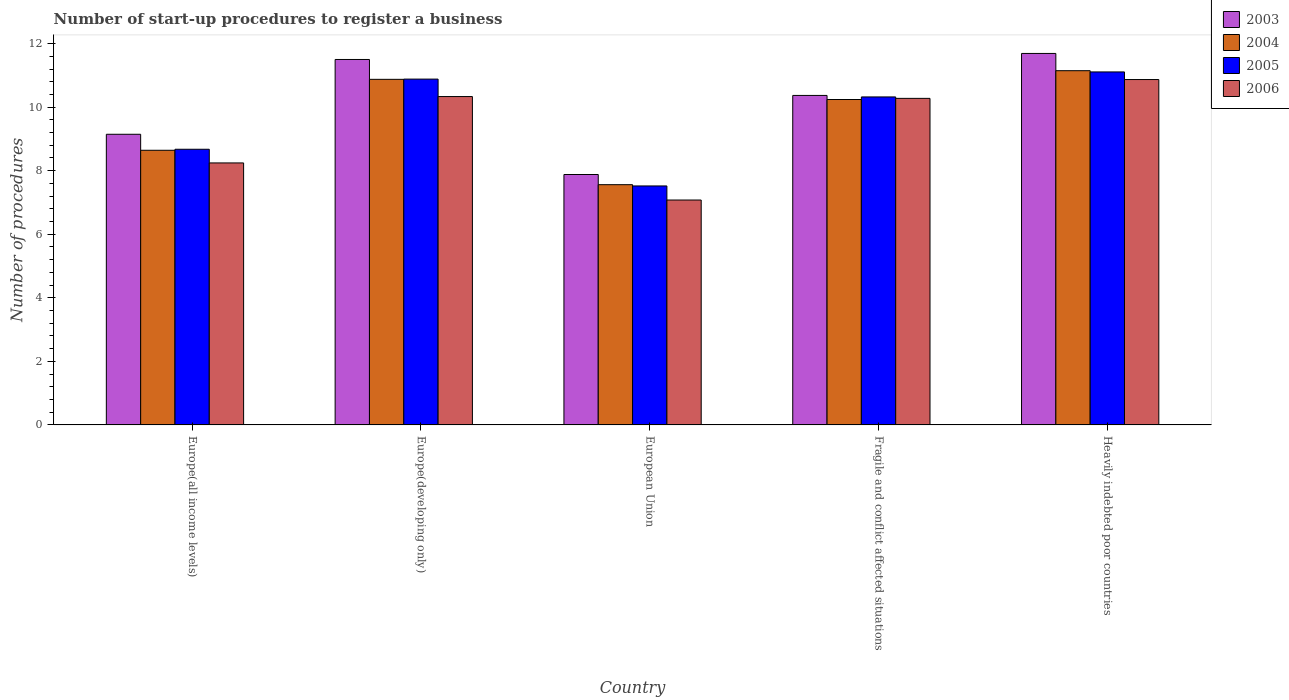How many bars are there on the 3rd tick from the left?
Your answer should be very brief. 4. In how many cases, is the number of bars for a given country not equal to the number of legend labels?
Offer a very short reply. 0. What is the number of procedures required to register a business in 2005 in Heavily indebted poor countries?
Your answer should be compact. 11.11. Across all countries, what is the maximum number of procedures required to register a business in 2003?
Make the answer very short. 11.69. Across all countries, what is the minimum number of procedures required to register a business in 2004?
Your response must be concise. 7.56. In which country was the number of procedures required to register a business in 2004 maximum?
Ensure brevity in your answer.  Heavily indebted poor countries. In which country was the number of procedures required to register a business in 2004 minimum?
Provide a succinct answer. European Union. What is the total number of procedures required to register a business in 2006 in the graph?
Offer a terse response. 46.8. What is the difference between the number of procedures required to register a business in 2005 in European Union and that in Fragile and conflict affected situations?
Ensure brevity in your answer.  -2.8. What is the difference between the number of procedures required to register a business in 2004 in Europe(all income levels) and the number of procedures required to register a business in 2003 in Fragile and conflict affected situations?
Your answer should be very brief. -1.73. What is the average number of procedures required to register a business in 2005 per country?
Your answer should be compact. 9.7. What is the difference between the number of procedures required to register a business of/in 2003 and number of procedures required to register a business of/in 2004 in European Union?
Keep it short and to the point. 0.32. In how many countries, is the number of procedures required to register a business in 2006 greater than 11.6?
Your response must be concise. 0. What is the ratio of the number of procedures required to register a business in 2005 in Europe(all income levels) to that in European Union?
Make the answer very short. 1.15. Is the number of procedures required to register a business in 2004 in Fragile and conflict affected situations less than that in Heavily indebted poor countries?
Offer a terse response. Yes. Is the difference between the number of procedures required to register a business in 2003 in European Union and Heavily indebted poor countries greater than the difference between the number of procedures required to register a business in 2004 in European Union and Heavily indebted poor countries?
Ensure brevity in your answer.  No. What is the difference between the highest and the second highest number of procedures required to register a business in 2003?
Your response must be concise. 1.13. What is the difference between the highest and the lowest number of procedures required to register a business in 2005?
Keep it short and to the point. 3.59. What does the 2nd bar from the right in European Union represents?
Ensure brevity in your answer.  2005. How many legend labels are there?
Provide a short and direct response. 4. What is the title of the graph?
Offer a very short reply. Number of start-up procedures to register a business. What is the label or title of the Y-axis?
Give a very brief answer. Number of procedures. What is the Number of procedures in 2003 in Europe(all income levels)?
Keep it short and to the point. 9.15. What is the Number of procedures of 2004 in Europe(all income levels)?
Ensure brevity in your answer.  8.64. What is the Number of procedures of 2005 in Europe(all income levels)?
Provide a succinct answer. 8.67. What is the Number of procedures in 2006 in Europe(all income levels)?
Keep it short and to the point. 8.24. What is the Number of procedures of 2004 in Europe(developing only)?
Your answer should be compact. 10.88. What is the Number of procedures in 2005 in Europe(developing only)?
Give a very brief answer. 10.88. What is the Number of procedures of 2006 in Europe(developing only)?
Give a very brief answer. 10.33. What is the Number of procedures of 2003 in European Union?
Provide a short and direct response. 7.88. What is the Number of procedures of 2004 in European Union?
Provide a short and direct response. 7.56. What is the Number of procedures in 2005 in European Union?
Your response must be concise. 7.52. What is the Number of procedures of 2006 in European Union?
Provide a succinct answer. 7.08. What is the Number of procedures in 2003 in Fragile and conflict affected situations?
Your answer should be very brief. 10.37. What is the Number of procedures in 2004 in Fragile and conflict affected situations?
Your response must be concise. 10.24. What is the Number of procedures of 2005 in Fragile and conflict affected situations?
Ensure brevity in your answer.  10.32. What is the Number of procedures of 2006 in Fragile and conflict affected situations?
Make the answer very short. 10.28. What is the Number of procedures of 2003 in Heavily indebted poor countries?
Offer a very short reply. 11.69. What is the Number of procedures of 2004 in Heavily indebted poor countries?
Provide a short and direct response. 11.15. What is the Number of procedures in 2005 in Heavily indebted poor countries?
Your answer should be very brief. 11.11. What is the Number of procedures of 2006 in Heavily indebted poor countries?
Provide a succinct answer. 10.87. Across all countries, what is the maximum Number of procedures in 2003?
Your response must be concise. 11.69. Across all countries, what is the maximum Number of procedures in 2004?
Offer a terse response. 11.15. Across all countries, what is the maximum Number of procedures in 2005?
Keep it short and to the point. 11.11. Across all countries, what is the maximum Number of procedures of 2006?
Ensure brevity in your answer.  10.87. Across all countries, what is the minimum Number of procedures in 2003?
Your answer should be very brief. 7.88. Across all countries, what is the minimum Number of procedures of 2004?
Give a very brief answer. 7.56. Across all countries, what is the minimum Number of procedures of 2005?
Your answer should be very brief. 7.52. Across all countries, what is the minimum Number of procedures in 2006?
Provide a short and direct response. 7.08. What is the total Number of procedures in 2003 in the graph?
Give a very brief answer. 50.58. What is the total Number of procedures of 2004 in the graph?
Make the answer very short. 48.46. What is the total Number of procedures of 2005 in the graph?
Your answer should be compact. 48.51. What is the total Number of procedures in 2006 in the graph?
Keep it short and to the point. 46.8. What is the difference between the Number of procedures of 2003 in Europe(all income levels) and that in Europe(developing only)?
Provide a succinct answer. -2.35. What is the difference between the Number of procedures in 2004 in Europe(all income levels) and that in Europe(developing only)?
Ensure brevity in your answer.  -2.23. What is the difference between the Number of procedures in 2005 in Europe(all income levels) and that in Europe(developing only)?
Give a very brief answer. -2.21. What is the difference between the Number of procedures of 2006 in Europe(all income levels) and that in Europe(developing only)?
Offer a terse response. -2.09. What is the difference between the Number of procedures in 2003 in Europe(all income levels) and that in European Union?
Keep it short and to the point. 1.27. What is the difference between the Number of procedures in 2004 in Europe(all income levels) and that in European Union?
Provide a succinct answer. 1.08. What is the difference between the Number of procedures in 2005 in Europe(all income levels) and that in European Union?
Provide a succinct answer. 1.15. What is the difference between the Number of procedures of 2006 in Europe(all income levels) and that in European Union?
Your response must be concise. 1.17. What is the difference between the Number of procedures of 2003 in Europe(all income levels) and that in Fragile and conflict affected situations?
Make the answer very short. -1.22. What is the difference between the Number of procedures of 2004 in Europe(all income levels) and that in Fragile and conflict affected situations?
Give a very brief answer. -1.6. What is the difference between the Number of procedures in 2005 in Europe(all income levels) and that in Fragile and conflict affected situations?
Provide a succinct answer. -1.65. What is the difference between the Number of procedures of 2006 in Europe(all income levels) and that in Fragile and conflict affected situations?
Provide a succinct answer. -2.03. What is the difference between the Number of procedures in 2003 in Europe(all income levels) and that in Heavily indebted poor countries?
Give a very brief answer. -2.54. What is the difference between the Number of procedures in 2004 in Europe(all income levels) and that in Heavily indebted poor countries?
Your answer should be compact. -2.5. What is the difference between the Number of procedures in 2005 in Europe(all income levels) and that in Heavily indebted poor countries?
Offer a very short reply. -2.43. What is the difference between the Number of procedures in 2006 in Europe(all income levels) and that in Heavily indebted poor countries?
Ensure brevity in your answer.  -2.62. What is the difference between the Number of procedures of 2003 in Europe(developing only) and that in European Union?
Offer a terse response. 3.62. What is the difference between the Number of procedures in 2004 in Europe(developing only) and that in European Union?
Give a very brief answer. 3.31. What is the difference between the Number of procedures of 2005 in Europe(developing only) and that in European Union?
Offer a terse response. 3.36. What is the difference between the Number of procedures of 2006 in Europe(developing only) and that in European Union?
Make the answer very short. 3.26. What is the difference between the Number of procedures of 2003 in Europe(developing only) and that in Fragile and conflict affected situations?
Give a very brief answer. 1.13. What is the difference between the Number of procedures in 2004 in Europe(developing only) and that in Fragile and conflict affected situations?
Provide a short and direct response. 0.64. What is the difference between the Number of procedures of 2005 in Europe(developing only) and that in Fragile and conflict affected situations?
Your answer should be compact. 0.56. What is the difference between the Number of procedures of 2006 in Europe(developing only) and that in Fragile and conflict affected situations?
Give a very brief answer. 0.06. What is the difference between the Number of procedures in 2003 in Europe(developing only) and that in Heavily indebted poor countries?
Offer a very short reply. -0.19. What is the difference between the Number of procedures of 2004 in Europe(developing only) and that in Heavily indebted poor countries?
Keep it short and to the point. -0.27. What is the difference between the Number of procedures in 2005 in Europe(developing only) and that in Heavily indebted poor countries?
Provide a short and direct response. -0.23. What is the difference between the Number of procedures of 2006 in Europe(developing only) and that in Heavily indebted poor countries?
Your answer should be compact. -0.54. What is the difference between the Number of procedures of 2003 in European Union and that in Fragile and conflict affected situations?
Ensure brevity in your answer.  -2.49. What is the difference between the Number of procedures in 2004 in European Union and that in Fragile and conflict affected situations?
Offer a terse response. -2.68. What is the difference between the Number of procedures in 2005 in European Union and that in Fragile and conflict affected situations?
Give a very brief answer. -2.8. What is the difference between the Number of procedures of 2006 in European Union and that in Fragile and conflict affected situations?
Give a very brief answer. -3.2. What is the difference between the Number of procedures of 2003 in European Union and that in Heavily indebted poor countries?
Ensure brevity in your answer.  -3.81. What is the difference between the Number of procedures in 2004 in European Union and that in Heavily indebted poor countries?
Make the answer very short. -3.59. What is the difference between the Number of procedures in 2005 in European Union and that in Heavily indebted poor countries?
Offer a terse response. -3.59. What is the difference between the Number of procedures in 2006 in European Union and that in Heavily indebted poor countries?
Give a very brief answer. -3.79. What is the difference between the Number of procedures of 2003 in Fragile and conflict affected situations and that in Heavily indebted poor countries?
Provide a short and direct response. -1.32. What is the difference between the Number of procedures in 2004 in Fragile and conflict affected situations and that in Heavily indebted poor countries?
Your answer should be compact. -0.91. What is the difference between the Number of procedures in 2005 in Fragile and conflict affected situations and that in Heavily indebted poor countries?
Ensure brevity in your answer.  -0.79. What is the difference between the Number of procedures in 2006 in Fragile and conflict affected situations and that in Heavily indebted poor countries?
Ensure brevity in your answer.  -0.59. What is the difference between the Number of procedures of 2003 in Europe(all income levels) and the Number of procedures of 2004 in Europe(developing only)?
Your response must be concise. -1.73. What is the difference between the Number of procedures in 2003 in Europe(all income levels) and the Number of procedures in 2005 in Europe(developing only)?
Offer a terse response. -1.74. What is the difference between the Number of procedures of 2003 in Europe(all income levels) and the Number of procedures of 2006 in Europe(developing only)?
Provide a short and direct response. -1.19. What is the difference between the Number of procedures in 2004 in Europe(all income levels) and the Number of procedures in 2005 in Europe(developing only)?
Offer a very short reply. -2.24. What is the difference between the Number of procedures of 2004 in Europe(all income levels) and the Number of procedures of 2006 in Europe(developing only)?
Offer a terse response. -1.69. What is the difference between the Number of procedures in 2005 in Europe(all income levels) and the Number of procedures in 2006 in Europe(developing only)?
Give a very brief answer. -1.66. What is the difference between the Number of procedures in 2003 in Europe(all income levels) and the Number of procedures in 2004 in European Union?
Your answer should be compact. 1.59. What is the difference between the Number of procedures in 2003 in Europe(all income levels) and the Number of procedures in 2005 in European Union?
Provide a succinct answer. 1.63. What is the difference between the Number of procedures in 2003 in Europe(all income levels) and the Number of procedures in 2006 in European Union?
Provide a short and direct response. 2.07. What is the difference between the Number of procedures in 2004 in Europe(all income levels) and the Number of procedures in 2005 in European Union?
Your answer should be very brief. 1.12. What is the difference between the Number of procedures of 2004 in Europe(all income levels) and the Number of procedures of 2006 in European Union?
Ensure brevity in your answer.  1.57. What is the difference between the Number of procedures of 2005 in Europe(all income levels) and the Number of procedures of 2006 in European Union?
Provide a succinct answer. 1.6. What is the difference between the Number of procedures of 2003 in Europe(all income levels) and the Number of procedures of 2004 in Fragile and conflict affected situations?
Keep it short and to the point. -1.09. What is the difference between the Number of procedures in 2003 in Europe(all income levels) and the Number of procedures in 2005 in Fragile and conflict affected situations?
Your answer should be very brief. -1.18. What is the difference between the Number of procedures of 2003 in Europe(all income levels) and the Number of procedures of 2006 in Fragile and conflict affected situations?
Offer a terse response. -1.13. What is the difference between the Number of procedures of 2004 in Europe(all income levels) and the Number of procedures of 2005 in Fragile and conflict affected situations?
Provide a succinct answer. -1.68. What is the difference between the Number of procedures in 2004 in Europe(all income levels) and the Number of procedures in 2006 in Fragile and conflict affected situations?
Ensure brevity in your answer.  -1.63. What is the difference between the Number of procedures of 2005 in Europe(all income levels) and the Number of procedures of 2006 in Fragile and conflict affected situations?
Ensure brevity in your answer.  -1.6. What is the difference between the Number of procedures in 2003 in Europe(all income levels) and the Number of procedures in 2004 in Heavily indebted poor countries?
Your answer should be compact. -2. What is the difference between the Number of procedures in 2003 in Europe(all income levels) and the Number of procedures in 2005 in Heavily indebted poor countries?
Ensure brevity in your answer.  -1.96. What is the difference between the Number of procedures in 2003 in Europe(all income levels) and the Number of procedures in 2006 in Heavily indebted poor countries?
Offer a terse response. -1.72. What is the difference between the Number of procedures in 2004 in Europe(all income levels) and the Number of procedures in 2005 in Heavily indebted poor countries?
Offer a very short reply. -2.47. What is the difference between the Number of procedures of 2004 in Europe(all income levels) and the Number of procedures of 2006 in Heavily indebted poor countries?
Your response must be concise. -2.23. What is the difference between the Number of procedures in 2005 in Europe(all income levels) and the Number of procedures in 2006 in Heavily indebted poor countries?
Keep it short and to the point. -2.19. What is the difference between the Number of procedures of 2003 in Europe(developing only) and the Number of procedures of 2004 in European Union?
Give a very brief answer. 3.94. What is the difference between the Number of procedures in 2003 in Europe(developing only) and the Number of procedures in 2005 in European Union?
Offer a terse response. 3.98. What is the difference between the Number of procedures in 2003 in Europe(developing only) and the Number of procedures in 2006 in European Union?
Provide a succinct answer. 4.42. What is the difference between the Number of procedures in 2004 in Europe(developing only) and the Number of procedures in 2005 in European Union?
Your answer should be compact. 3.35. What is the difference between the Number of procedures in 2004 in Europe(developing only) and the Number of procedures in 2006 in European Union?
Offer a very short reply. 3.8. What is the difference between the Number of procedures in 2005 in Europe(developing only) and the Number of procedures in 2006 in European Union?
Your answer should be very brief. 3.81. What is the difference between the Number of procedures of 2003 in Europe(developing only) and the Number of procedures of 2004 in Fragile and conflict affected situations?
Make the answer very short. 1.26. What is the difference between the Number of procedures of 2003 in Europe(developing only) and the Number of procedures of 2005 in Fragile and conflict affected situations?
Your answer should be very brief. 1.18. What is the difference between the Number of procedures of 2003 in Europe(developing only) and the Number of procedures of 2006 in Fragile and conflict affected situations?
Give a very brief answer. 1.22. What is the difference between the Number of procedures of 2004 in Europe(developing only) and the Number of procedures of 2005 in Fragile and conflict affected situations?
Offer a very short reply. 0.55. What is the difference between the Number of procedures of 2004 in Europe(developing only) and the Number of procedures of 2006 in Fragile and conflict affected situations?
Your response must be concise. 0.6. What is the difference between the Number of procedures in 2005 in Europe(developing only) and the Number of procedures in 2006 in Fragile and conflict affected situations?
Offer a terse response. 0.61. What is the difference between the Number of procedures of 2003 in Europe(developing only) and the Number of procedures of 2004 in Heavily indebted poor countries?
Your answer should be compact. 0.35. What is the difference between the Number of procedures of 2003 in Europe(developing only) and the Number of procedures of 2005 in Heavily indebted poor countries?
Provide a succinct answer. 0.39. What is the difference between the Number of procedures in 2003 in Europe(developing only) and the Number of procedures in 2006 in Heavily indebted poor countries?
Keep it short and to the point. 0.63. What is the difference between the Number of procedures of 2004 in Europe(developing only) and the Number of procedures of 2005 in Heavily indebted poor countries?
Your response must be concise. -0.23. What is the difference between the Number of procedures of 2004 in Europe(developing only) and the Number of procedures of 2006 in Heavily indebted poor countries?
Your answer should be very brief. 0.01. What is the difference between the Number of procedures in 2005 in Europe(developing only) and the Number of procedures in 2006 in Heavily indebted poor countries?
Your answer should be compact. 0.01. What is the difference between the Number of procedures in 2003 in European Union and the Number of procedures in 2004 in Fragile and conflict affected situations?
Keep it short and to the point. -2.36. What is the difference between the Number of procedures in 2003 in European Union and the Number of procedures in 2005 in Fragile and conflict affected situations?
Your answer should be compact. -2.44. What is the difference between the Number of procedures of 2003 in European Union and the Number of procedures of 2006 in Fragile and conflict affected situations?
Offer a terse response. -2.4. What is the difference between the Number of procedures in 2004 in European Union and the Number of procedures in 2005 in Fragile and conflict affected situations?
Ensure brevity in your answer.  -2.76. What is the difference between the Number of procedures of 2004 in European Union and the Number of procedures of 2006 in Fragile and conflict affected situations?
Offer a terse response. -2.72. What is the difference between the Number of procedures in 2005 in European Union and the Number of procedures in 2006 in Fragile and conflict affected situations?
Give a very brief answer. -2.76. What is the difference between the Number of procedures of 2003 in European Union and the Number of procedures of 2004 in Heavily indebted poor countries?
Offer a terse response. -3.27. What is the difference between the Number of procedures of 2003 in European Union and the Number of procedures of 2005 in Heavily indebted poor countries?
Make the answer very short. -3.23. What is the difference between the Number of procedures of 2003 in European Union and the Number of procedures of 2006 in Heavily indebted poor countries?
Give a very brief answer. -2.99. What is the difference between the Number of procedures in 2004 in European Union and the Number of procedures in 2005 in Heavily indebted poor countries?
Make the answer very short. -3.55. What is the difference between the Number of procedures of 2004 in European Union and the Number of procedures of 2006 in Heavily indebted poor countries?
Keep it short and to the point. -3.31. What is the difference between the Number of procedures in 2005 in European Union and the Number of procedures in 2006 in Heavily indebted poor countries?
Offer a very short reply. -3.35. What is the difference between the Number of procedures of 2003 in Fragile and conflict affected situations and the Number of procedures of 2004 in Heavily indebted poor countries?
Keep it short and to the point. -0.78. What is the difference between the Number of procedures of 2003 in Fragile and conflict affected situations and the Number of procedures of 2005 in Heavily indebted poor countries?
Your answer should be compact. -0.74. What is the difference between the Number of procedures in 2004 in Fragile and conflict affected situations and the Number of procedures in 2005 in Heavily indebted poor countries?
Offer a very short reply. -0.87. What is the difference between the Number of procedures in 2004 in Fragile and conflict affected situations and the Number of procedures in 2006 in Heavily indebted poor countries?
Ensure brevity in your answer.  -0.63. What is the difference between the Number of procedures in 2005 in Fragile and conflict affected situations and the Number of procedures in 2006 in Heavily indebted poor countries?
Offer a terse response. -0.55. What is the average Number of procedures in 2003 per country?
Ensure brevity in your answer.  10.12. What is the average Number of procedures of 2004 per country?
Your answer should be very brief. 9.69. What is the average Number of procedures of 2005 per country?
Keep it short and to the point. 9.7. What is the average Number of procedures of 2006 per country?
Give a very brief answer. 9.36. What is the difference between the Number of procedures in 2003 and Number of procedures in 2004 in Europe(all income levels)?
Make the answer very short. 0.5. What is the difference between the Number of procedures in 2003 and Number of procedures in 2005 in Europe(all income levels)?
Your answer should be compact. 0.47. What is the difference between the Number of procedures in 2003 and Number of procedures in 2006 in Europe(all income levels)?
Your response must be concise. 0.9. What is the difference between the Number of procedures in 2004 and Number of procedures in 2005 in Europe(all income levels)?
Your response must be concise. -0.03. What is the difference between the Number of procedures in 2004 and Number of procedures in 2006 in Europe(all income levels)?
Offer a very short reply. 0.4. What is the difference between the Number of procedures of 2005 and Number of procedures of 2006 in Europe(all income levels)?
Make the answer very short. 0.43. What is the difference between the Number of procedures in 2003 and Number of procedures in 2004 in Europe(developing only)?
Keep it short and to the point. 0.62. What is the difference between the Number of procedures in 2003 and Number of procedures in 2005 in Europe(developing only)?
Make the answer very short. 0.62. What is the difference between the Number of procedures of 2003 and Number of procedures of 2006 in Europe(developing only)?
Ensure brevity in your answer.  1.17. What is the difference between the Number of procedures of 2004 and Number of procedures of 2005 in Europe(developing only)?
Offer a terse response. -0.01. What is the difference between the Number of procedures of 2004 and Number of procedures of 2006 in Europe(developing only)?
Your answer should be compact. 0.54. What is the difference between the Number of procedures in 2005 and Number of procedures in 2006 in Europe(developing only)?
Make the answer very short. 0.55. What is the difference between the Number of procedures in 2003 and Number of procedures in 2004 in European Union?
Your answer should be compact. 0.32. What is the difference between the Number of procedures in 2003 and Number of procedures in 2005 in European Union?
Keep it short and to the point. 0.36. What is the difference between the Number of procedures of 2003 and Number of procedures of 2006 in European Union?
Give a very brief answer. 0.8. What is the difference between the Number of procedures of 2004 and Number of procedures of 2005 in European Union?
Give a very brief answer. 0.04. What is the difference between the Number of procedures of 2004 and Number of procedures of 2006 in European Union?
Make the answer very short. 0.48. What is the difference between the Number of procedures in 2005 and Number of procedures in 2006 in European Union?
Make the answer very short. 0.44. What is the difference between the Number of procedures in 2003 and Number of procedures in 2004 in Fragile and conflict affected situations?
Offer a very short reply. 0.13. What is the difference between the Number of procedures of 2003 and Number of procedures of 2005 in Fragile and conflict affected situations?
Provide a succinct answer. 0.05. What is the difference between the Number of procedures in 2003 and Number of procedures in 2006 in Fragile and conflict affected situations?
Provide a short and direct response. 0.09. What is the difference between the Number of procedures of 2004 and Number of procedures of 2005 in Fragile and conflict affected situations?
Provide a succinct answer. -0.08. What is the difference between the Number of procedures in 2004 and Number of procedures in 2006 in Fragile and conflict affected situations?
Give a very brief answer. -0.04. What is the difference between the Number of procedures in 2005 and Number of procedures in 2006 in Fragile and conflict affected situations?
Provide a short and direct response. 0.05. What is the difference between the Number of procedures of 2003 and Number of procedures of 2004 in Heavily indebted poor countries?
Offer a very short reply. 0.54. What is the difference between the Number of procedures of 2003 and Number of procedures of 2005 in Heavily indebted poor countries?
Give a very brief answer. 0.58. What is the difference between the Number of procedures of 2003 and Number of procedures of 2006 in Heavily indebted poor countries?
Give a very brief answer. 0.82. What is the difference between the Number of procedures in 2004 and Number of procedures in 2005 in Heavily indebted poor countries?
Your answer should be very brief. 0.04. What is the difference between the Number of procedures of 2004 and Number of procedures of 2006 in Heavily indebted poor countries?
Give a very brief answer. 0.28. What is the difference between the Number of procedures in 2005 and Number of procedures in 2006 in Heavily indebted poor countries?
Make the answer very short. 0.24. What is the ratio of the Number of procedures of 2003 in Europe(all income levels) to that in Europe(developing only)?
Ensure brevity in your answer.  0.8. What is the ratio of the Number of procedures of 2004 in Europe(all income levels) to that in Europe(developing only)?
Provide a succinct answer. 0.79. What is the ratio of the Number of procedures of 2005 in Europe(all income levels) to that in Europe(developing only)?
Ensure brevity in your answer.  0.8. What is the ratio of the Number of procedures of 2006 in Europe(all income levels) to that in Europe(developing only)?
Ensure brevity in your answer.  0.8. What is the ratio of the Number of procedures in 2003 in Europe(all income levels) to that in European Union?
Give a very brief answer. 1.16. What is the ratio of the Number of procedures in 2004 in Europe(all income levels) to that in European Union?
Give a very brief answer. 1.14. What is the ratio of the Number of procedures of 2005 in Europe(all income levels) to that in European Union?
Offer a very short reply. 1.15. What is the ratio of the Number of procedures in 2006 in Europe(all income levels) to that in European Union?
Provide a succinct answer. 1.17. What is the ratio of the Number of procedures in 2003 in Europe(all income levels) to that in Fragile and conflict affected situations?
Offer a terse response. 0.88. What is the ratio of the Number of procedures in 2004 in Europe(all income levels) to that in Fragile and conflict affected situations?
Give a very brief answer. 0.84. What is the ratio of the Number of procedures in 2005 in Europe(all income levels) to that in Fragile and conflict affected situations?
Give a very brief answer. 0.84. What is the ratio of the Number of procedures of 2006 in Europe(all income levels) to that in Fragile and conflict affected situations?
Provide a short and direct response. 0.8. What is the ratio of the Number of procedures of 2003 in Europe(all income levels) to that in Heavily indebted poor countries?
Your answer should be very brief. 0.78. What is the ratio of the Number of procedures of 2004 in Europe(all income levels) to that in Heavily indebted poor countries?
Ensure brevity in your answer.  0.78. What is the ratio of the Number of procedures in 2005 in Europe(all income levels) to that in Heavily indebted poor countries?
Offer a terse response. 0.78. What is the ratio of the Number of procedures of 2006 in Europe(all income levels) to that in Heavily indebted poor countries?
Provide a short and direct response. 0.76. What is the ratio of the Number of procedures in 2003 in Europe(developing only) to that in European Union?
Offer a very short reply. 1.46. What is the ratio of the Number of procedures of 2004 in Europe(developing only) to that in European Union?
Provide a succinct answer. 1.44. What is the ratio of the Number of procedures in 2005 in Europe(developing only) to that in European Union?
Provide a short and direct response. 1.45. What is the ratio of the Number of procedures in 2006 in Europe(developing only) to that in European Union?
Your answer should be very brief. 1.46. What is the ratio of the Number of procedures in 2003 in Europe(developing only) to that in Fragile and conflict affected situations?
Offer a terse response. 1.11. What is the ratio of the Number of procedures of 2004 in Europe(developing only) to that in Fragile and conflict affected situations?
Your answer should be compact. 1.06. What is the ratio of the Number of procedures of 2005 in Europe(developing only) to that in Fragile and conflict affected situations?
Ensure brevity in your answer.  1.05. What is the ratio of the Number of procedures of 2006 in Europe(developing only) to that in Fragile and conflict affected situations?
Your response must be concise. 1.01. What is the ratio of the Number of procedures in 2003 in Europe(developing only) to that in Heavily indebted poor countries?
Make the answer very short. 0.98. What is the ratio of the Number of procedures in 2004 in Europe(developing only) to that in Heavily indebted poor countries?
Provide a succinct answer. 0.98. What is the ratio of the Number of procedures of 2005 in Europe(developing only) to that in Heavily indebted poor countries?
Ensure brevity in your answer.  0.98. What is the ratio of the Number of procedures of 2006 in Europe(developing only) to that in Heavily indebted poor countries?
Your answer should be compact. 0.95. What is the ratio of the Number of procedures in 2003 in European Union to that in Fragile and conflict affected situations?
Your answer should be compact. 0.76. What is the ratio of the Number of procedures of 2004 in European Union to that in Fragile and conflict affected situations?
Give a very brief answer. 0.74. What is the ratio of the Number of procedures of 2005 in European Union to that in Fragile and conflict affected situations?
Provide a short and direct response. 0.73. What is the ratio of the Number of procedures in 2006 in European Union to that in Fragile and conflict affected situations?
Make the answer very short. 0.69. What is the ratio of the Number of procedures in 2003 in European Union to that in Heavily indebted poor countries?
Provide a succinct answer. 0.67. What is the ratio of the Number of procedures in 2004 in European Union to that in Heavily indebted poor countries?
Provide a succinct answer. 0.68. What is the ratio of the Number of procedures of 2005 in European Union to that in Heavily indebted poor countries?
Your response must be concise. 0.68. What is the ratio of the Number of procedures of 2006 in European Union to that in Heavily indebted poor countries?
Your answer should be very brief. 0.65. What is the ratio of the Number of procedures of 2003 in Fragile and conflict affected situations to that in Heavily indebted poor countries?
Ensure brevity in your answer.  0.89. What is the ratio of the Number of procedures in 2004 in Fragile and conflict affected situations to that in Heavily indebted poor countries?
Give a very brief answer. 0.92. What is the ratio of the Number of procedures in 2005 in Fragile and conflict affected situations to that in Heavily indebted poor countries?
Provide a short and direct response. 0.93. What is the ratio of the Number of procedures in 2006 in Fragile and conflict affected situations to that in Heavily indebted poor countries?
Your answer should be compact. 0.95. What is the difference between the highest and the second highest Number of procedures in 2003?
Offer a very short reply. 0.19. What is the difference between the highest and the second highest Number of procedures of 2004?
Your answer should be very brief. 0.27. What is the difference between the highest and the second highest Number of procedures of 2005?
Your answer should be compact. 0.23. What is the difference between the highest and the second highest Number of procedures in 2006?
Make the answer very short. 0.54. What is the difference between the highest and the lowest Number of procedures of 2003?
Ensure brevity in your answer.  3.81. What is the difference between the highest and the lowest Number of procedures of 2004?
Your answer should be very brief. 3.59. What is the difference between the highest and the lowest Number of procedures in 2005?
Make the answer very short. 3.59. What is the difference between the highest and the lowest Number of procedures of 2006?
Provide a short and direct response. 3.79. 